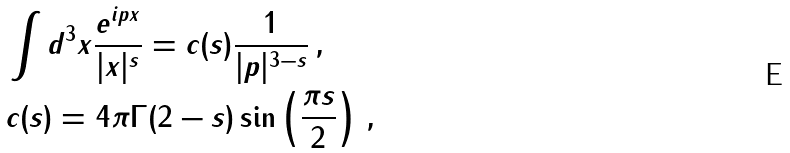Convert formula to latex. <formula><loc_0><loc_0><loc_500><loc_500>& \int d ^ { 3 } x \frac { e ^ { i p x } } { | x | ^ { s } } = c ( s ) \frac { 1 } { | p | ^ { 3 - s } } \, , \\ & c ( s ) = 4 \pi \Gamma ( 2 - s ) \sin \left ( \frac { \pi s } { 2 } \right ) \, ,</formula> 